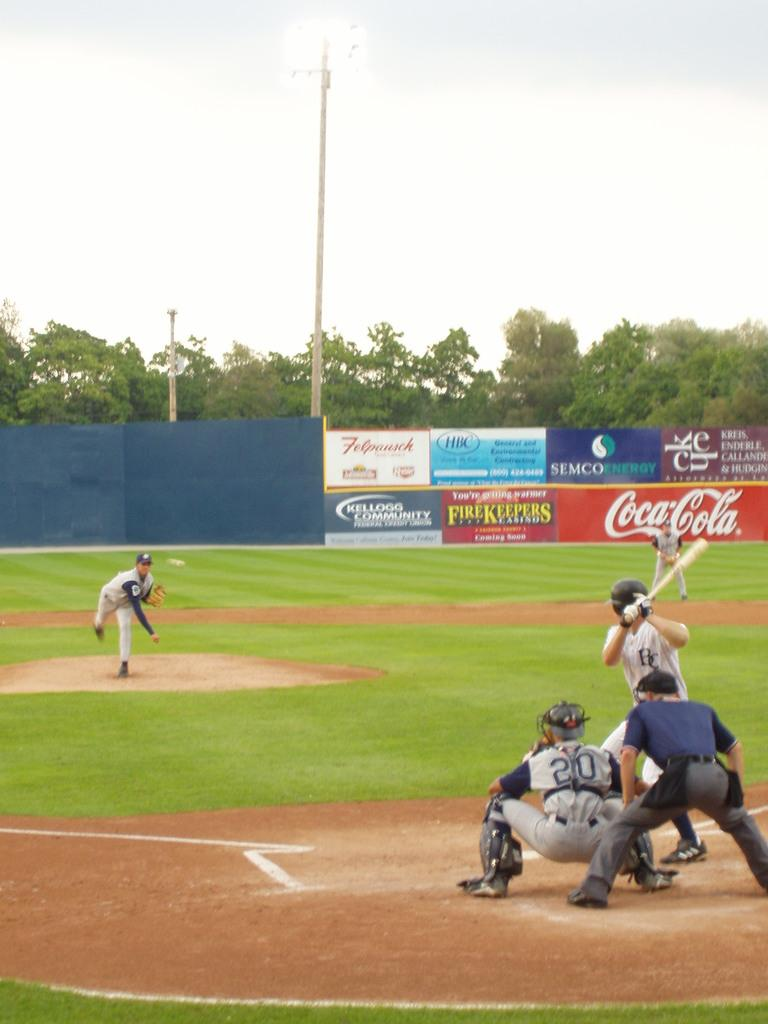Provide a one-sentence caption for the provided image. Coca-Cola is one of many companies with banners on the ball of a baseball field where a game in underway. 